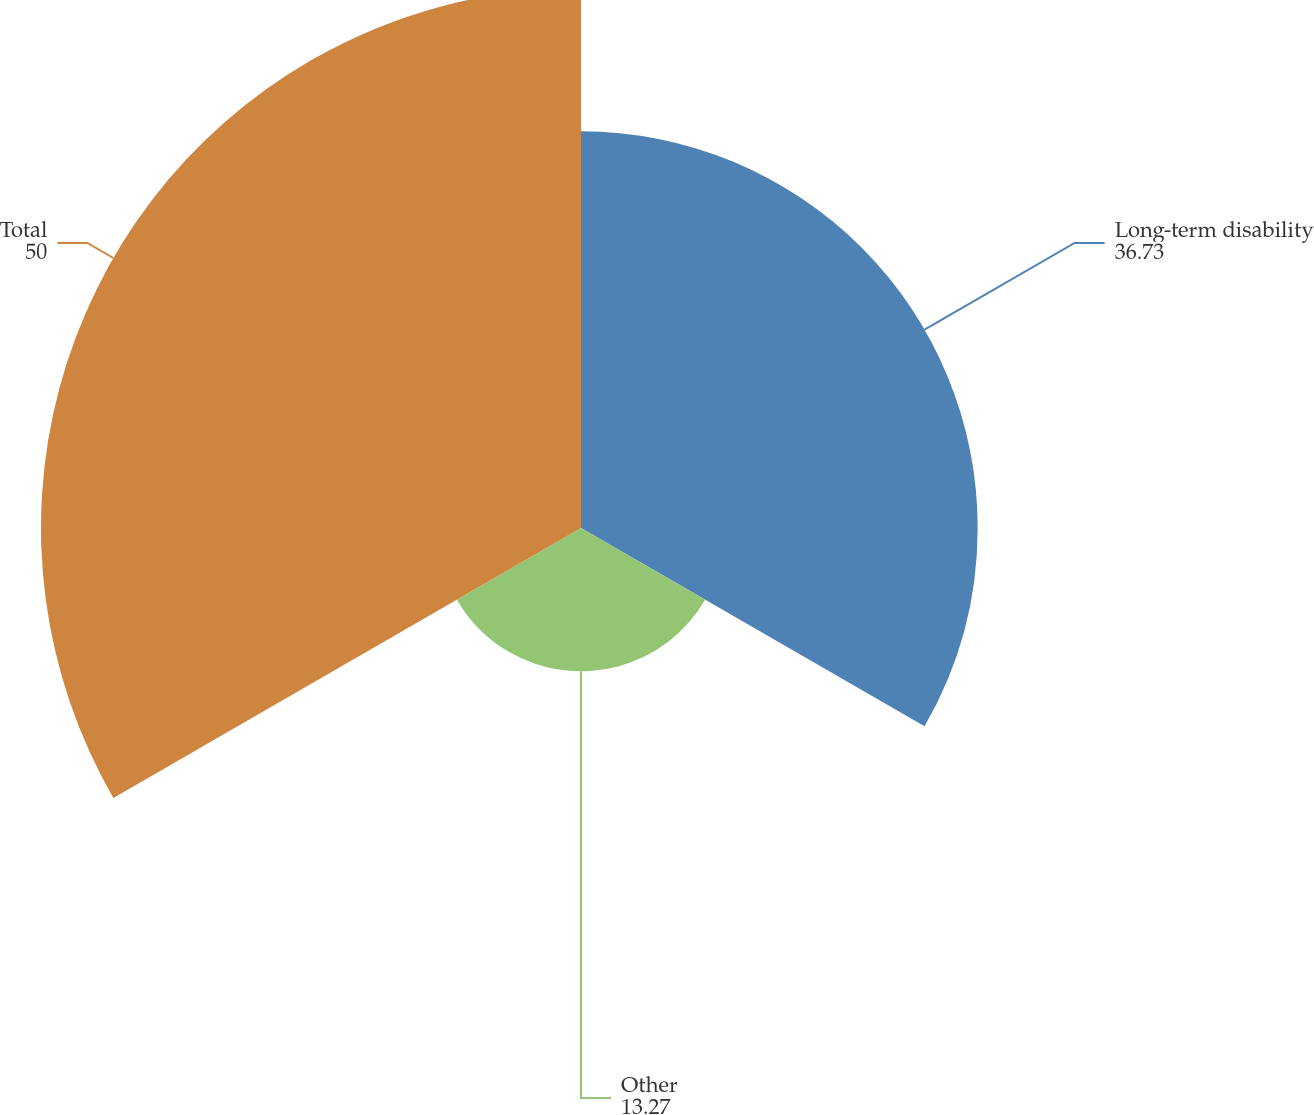<chart> <loc_0><loc_0><loc_500><loc_500><pie_chart><fcel>Long-term disability<fcel>Other<fcel>Total<nl><fcel>36.73%<fcel>13.27%<fcel>50.0%<nl></chart> 